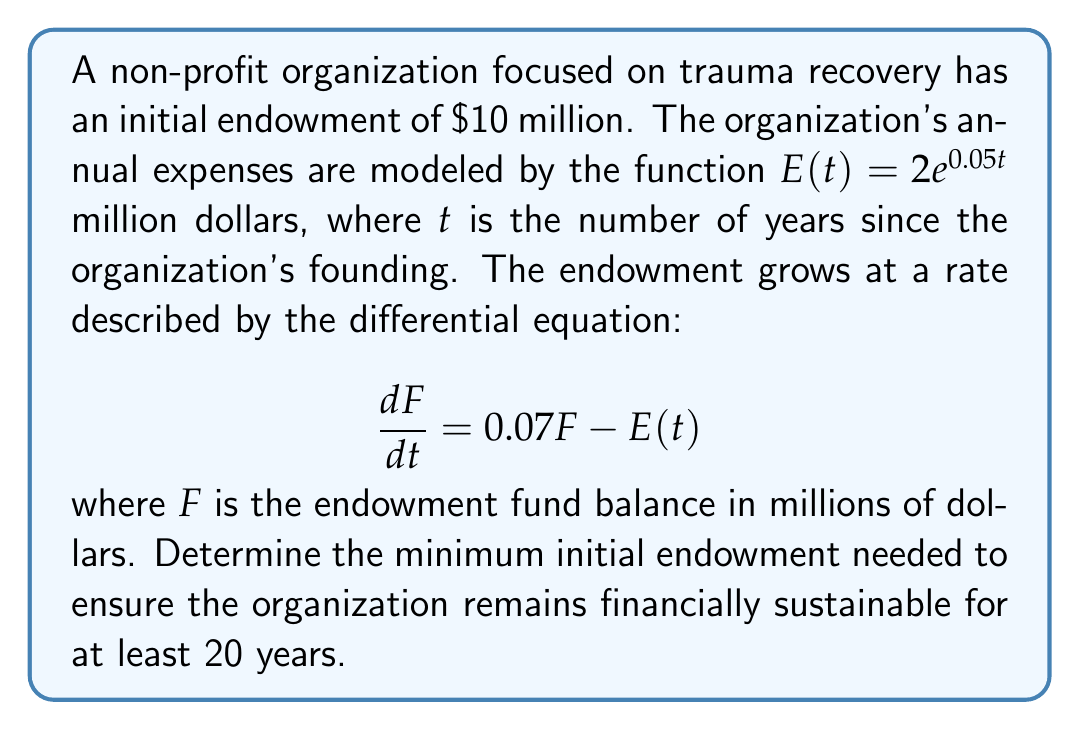Show me your answer to this math problem. To solve this problem, we'll follow these steps:

1) First, we need to solve the differential equation:
   $$\frac{dF}{dt} = 0.07F - 2e^{0.05t}$$

2) This is a linear first-order differential equation. The general solution is:
   $$F(t) = e^{0.07t}(C - \int 2e^{-0.02t}dt)$$
   where $C$ is a constant of integration.

3) Solving the integral:
   $$F(t) = e^{0.07t}(C + 100e^{-0.02t}) = Ce^{0.07t} + 100e^{0.05t}$$

4) Using the initial condition $F(0) = 10$:
   $$10 = C + 100$$
   $$C = -90$$

5) Therefore, the particular solution is:
   $$F(t) = -90e^{0.07t} + 100e^{0.05t}$$

6) To ensure financial sustainability, we need $F(t) > 0$ for all $t \leq 20$. Let's find the minimum of $F(t)$ in this interval:
   $$F'(t) = -6.3e^{0.07t} + 5e^{0.05t}$$

7) Setting $F'(t) = 0$:
   $$-6.3e^{0.07t} + 5e^{0.05t} = 0$$
   $$e^{0.02t} = \frac{5}{6.3} \approx 0.7937$$
   $$t \approx 11.61$$

8) This critical point is within our interval. Evaluating $F(11.61)$:
   $$F(11.61) \approx -90e^{0.07(11.61)} + 100e^{0.05(11.61)} \approx -0.8042$$

9) Since $F(11.61) < 0$, the organization becomes insolvent before 20 years with the current endowment.

10) To find the minimum initial endowment, we can scale our solution:
    $$F(t) = k(-90e^{0.07t} + 100e^{0.05t})$$
    where $k$ is the scaling factor.

11) We want $F(11.61) = 0$:
    $$k(-90e^{0.07(11.61)} + 100e^{0.05(11.61)}) = 0$$
    $$k \approx 1.0804$$

12) Therefore, the minimum initial endowment needed is:
    $$10 \text{ million} \times 1.0804 \approx 10.804 \text{ million dollars}$$
Answer: $10.804 million 